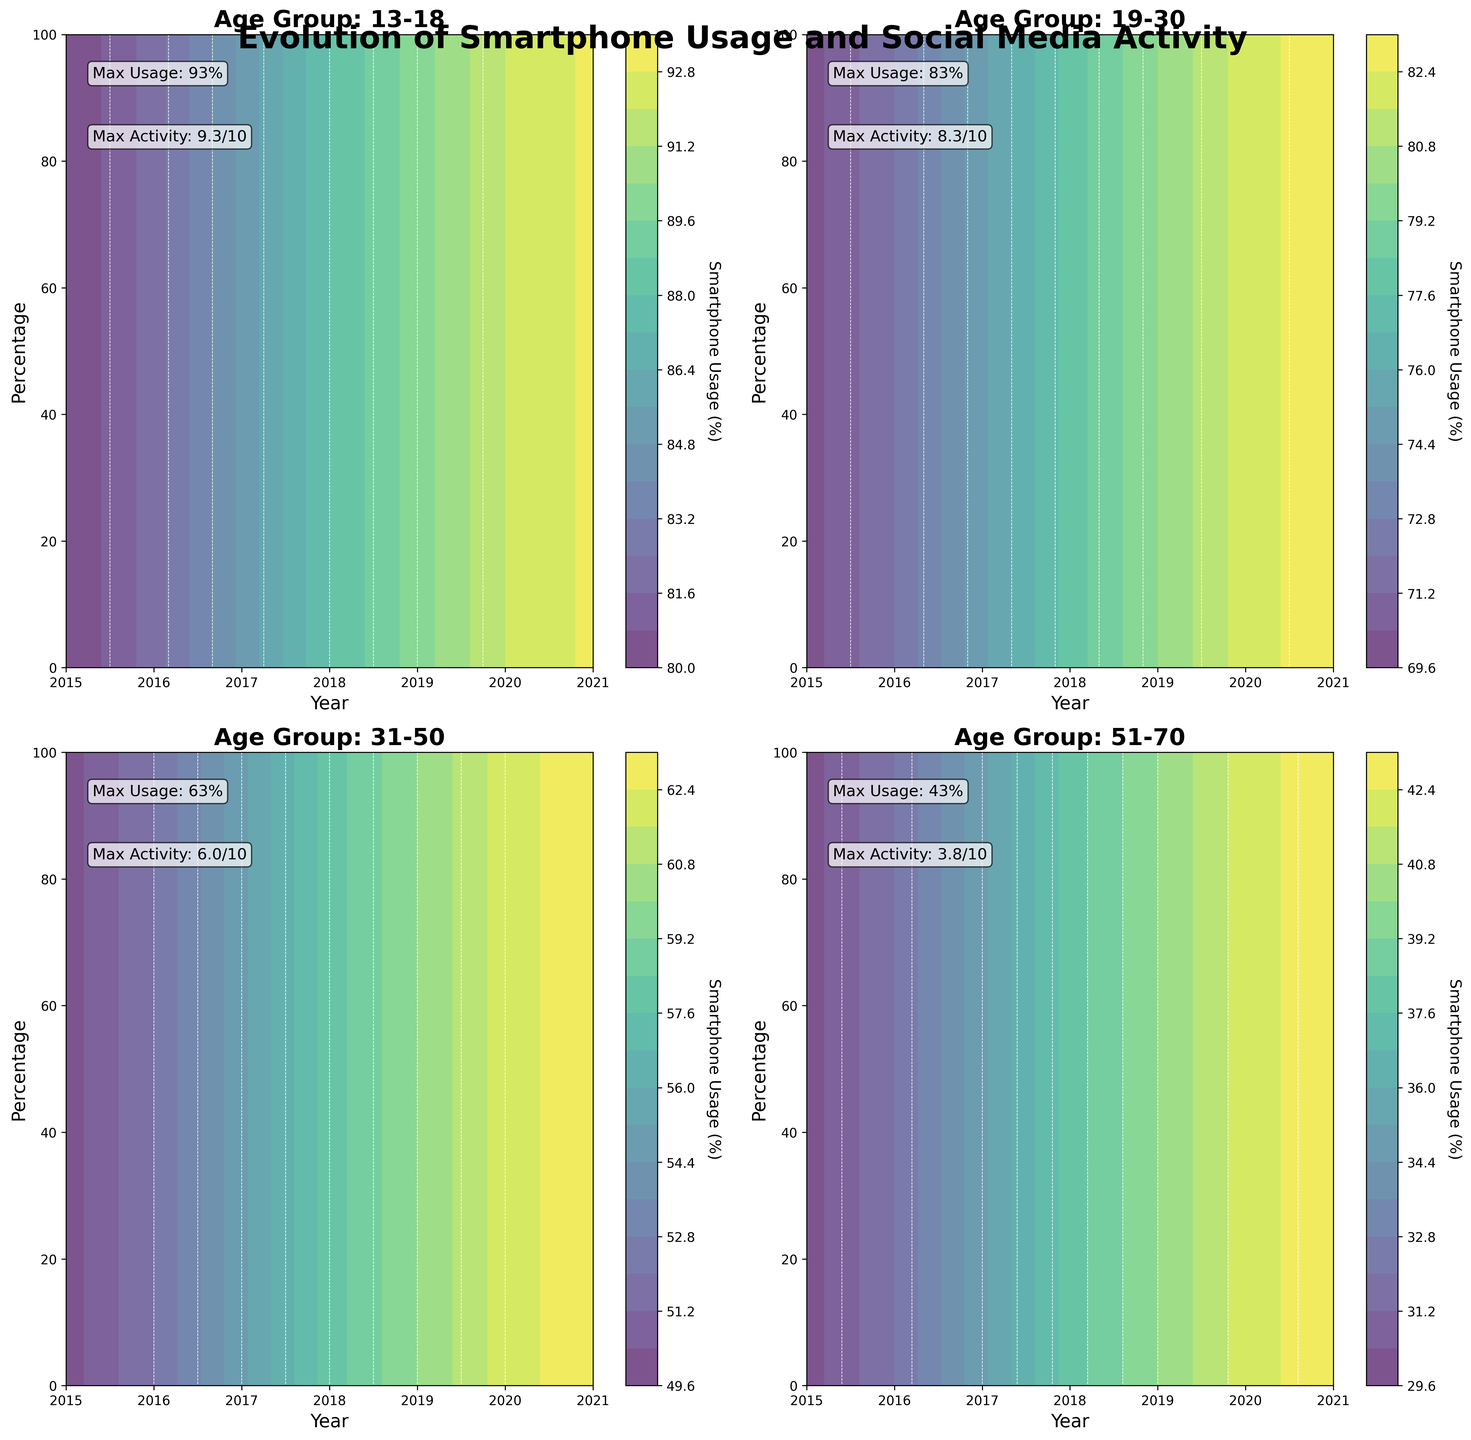What is the title of the figure? The title is given at the top of the figure and summarizes the main topic of the visual representation.
Answer: Evolution of Smartphone Usage and Social Media Activity Which age group has the highest max smartphone usage in 2021? By looking at the subplot titles and checking the max usage annotations or the color levels, we can determine that the 13-18 age group has the highest max usage.
Answer: 13-18 What is the maximum social media activity level for the age group 31-50? We need to refer to the annotation inside the subplot labeled "Age Group: 31-50" to find the max activity level.
Answer: 6/10 Compare the smartphone usage between the 19-30 and 31-50 age groups in 2018. Which one is higher? By checking the contour levels for each age group in their respective subplots for the year 2018, we see that the 19-30 age group has higher smartphone usage.
Answer: 19-30 By how much did the smartphone usage increase for the age group 51-70 from 2015 to 2021? Subtract the percentage in 2015 from the percentage in 2021 for the 51-70 age group. 43% (2021) - 30% (2015) = 13%.
Answer: 13% Is social media activity level directly proportional to smartphone usage for the age group 13-18 over the years? Observing the annotations and contour lines, we see that both metrics increase consistently over the years for this age group, indicating a direct proportionality.
Answer: Yes What is the average max social media activity level across all age groups? Summing up the max activity levels for each age group (9.3 + 8.3 + 6 + 3.8) and dividing by 4 gives (27.4 / 4) = 6.85.
Answer: 6.85 Which age group shows the least growth in smartphone usage from 2015 to 2021? By comparing the difference in smartphone usage percentages from 2015 to 2021 across age groups, the 51-70 age group shows the smallest increase (13% growth).
Answer: 51-70 Do any age groups have overlapping smartphone usage percentages in 2017? If yes, which ones? By examining 2017 for overlap in percentage usage within the contours of different subplots, we see no overlapping percentages explicitly.
Answer: No 